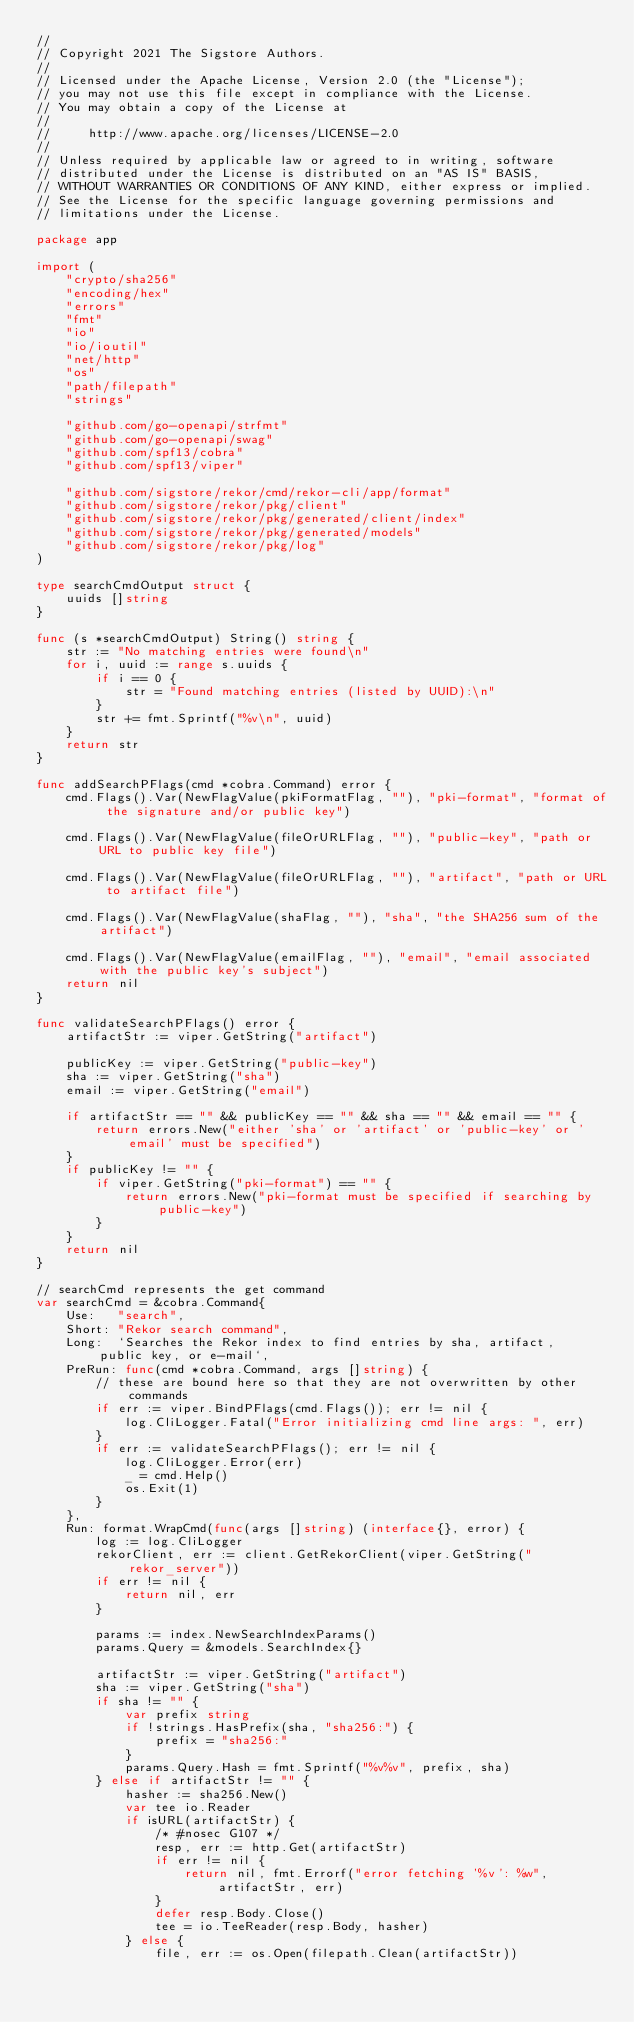Convert code to text. <code><loc_0><loc_0><loc_500><loc_500><_Go_>//
// Copyright 2021 The Sigstore Authors.
//
// Licensed under the Apache License, Version 2.0 (the "License");
// you may not use this file except in compliance with the License.
// You may obtain a copy of the License at
//
//     http://www.apache.org/licenses/LICENSE-2.0
//
// Unless required by applicable law or agreed to in writing, software
// distributed under the License is distributed on an "AS IS" BASIS,
// WITHOUT WARRANTIES OR CONDITIONS OF ANY KIND, either express or implied.
// See the License for the specific language governing permissions and
// limitations under the License.

package app

import (
	"crypto/sha256"
	"encoding/hex"
	"errors"
	"fmt"
	"io"
	"io/ioutil"
	"net/http"
	"os"
	"path/filepath"
	"strings"

	"github.com/go-openapi/strfmt"
	"github.com/go-openapi/swag"
	"github.com/spf13/cobra"
	"github.com/spf13/viper"

	"github.com/sigstore/rekor/cmd/rekor-cli/app/format"
	"github.com/sigstore/rekor/pkg/client"
	"github.com/sigstore/rekor/pkg/generated/client/index"
	"github.com/sigstore/rekor/pkg/generated/models"
	"github.com/sigstore/rekor/pkg/log"
)

type searchCmdOutput struct {
	uuids []string
}

func (s *searchCmdOutput) String() string {
	str := "No matching entries were found\n"
	for i, uuid := range s.uuids {
		if i == 0 {
			str = "Found matching entries (listed by UUID):\n"
		}
		str += fmt.Sprintf("%v\n", uuid)
	}
	return str
}

func addSearchPFlags(cmd *cobra.Command) error {
	cmd.Flags().Var(NewFlagValue(pkiFormatFlag, ""), "pki-format", "format of the signature and/or public key")

	cmd.Flags().Var(NewFlagValue(fileOrURLFlag, ""), "public-key", "path or URL to public key file")

	cmd.Flags().Var(NewFlagValue(fileOrURLFlag, ""), "artifact", "path or URL to artifact file")

	cmd.Flags().Var(NewFlagValue(shaFlag, ""), "sha", "the SHA256 sum of the artifact")

	cmd.Flags().Var(NewFlagValue(emailFlag, ""), "email", "email associated with the public key's subject")
	return nil
}

func validateSearchPFlags() error {
	artifactStr := viper.GetString("artifact")

	publicKey := viper.GetString("public-key")
	sha := viper.GetString("sha")
	email := viper.GetString("email")

	if artifactStr == "" && publicKey == "" && sha == "" && email == "" {
		return errors.New("either 'sha' or 'artifact' or 'public-key' or 'email' must be specified")
	}
	if publicKey != "" {
		if viper.GetString("pki-format") == "" {
			return errors.New("pki-format must be specified if searching by public-key")
		}
	}
	return nil
}

// searchCmd represents the get command
var searchCmd = &cobra.Command{
	Use:   "search",
	Short: "Rekor search command",
	Long:  `Searches the Rekor index to find entries by sha, artifact,  public key, or e-mail`,
	PreRun: func(cmd *cobra.Command, args []string) {
		// these are bound here so that they are not overwritten by other commands
		if err := viper.BindPFlags(cmd.Flags()); err != nil {
			log.CliLogger.Fatal("Error initializing cmd line args: ", err)
		}
		if err := validateSearchPFlags(); err != nil {
			log.CliLogger.Error(err)
			_ = cmd.Help()
			os.Exit(1)
		}
	},
	Run: format.WrapCmd(func(args []string) (interface{}, error) {
		log := log.CliLogger
		rekorClient, err := client.GetRekorClient(viper.GetString("rekor_server"))
		if err != nil {
			return nil, err
		}

		params := index.NewSearchIndexParams()
		params.Query = &models.SearchIndex{}

		artifactStr := viper.GetString("artifact")
		sha := viper.GetString("sha")
		if sha != "" {
			var prefix string
			if !strings.HasPrefix(sha, "sha256:") {
				prefix = "sha256:"
			}
			params.Query.Hash = fmt.Sprintf("%v%v", prefix, sha)
		} else if artifactStr != "" {
			hasher := sha256.New()
			var tee io.Reader
			if isURL(artifactStr) {
				/* #nosec G107 */
				resp, err := http.Get(artifactStr)
				if err != nil {
					return nil, fmt.Errorf("error fetching '%v': %w", artifactStr, err)
				}
				defer resp.Body.Close()
				tee = io.TeeReader(resp.Body, hasher)
			} else {
				file, err := os.Open(filepath.Clean(artifactStr))</code> 